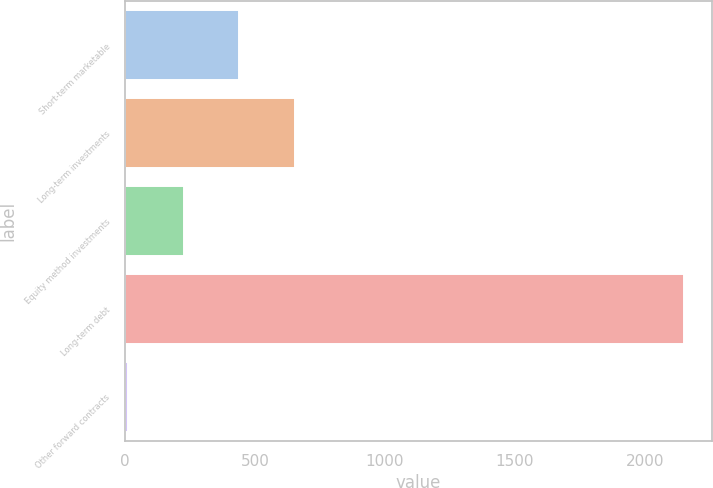Convert chart to OTSL. <chart><loc_0><loc_0><loc_500><loc_500><bar_chart><fcel>Short-term marketable<fcel>Long-term investments<fcel>Equity method investments<fcel>Long-term debt<fcel>Other forward contracts<nl><fcel>439.04<fcel>652.81<fcel>225.27<fcel>2149.2<fcel>11.5<nl></chart> 